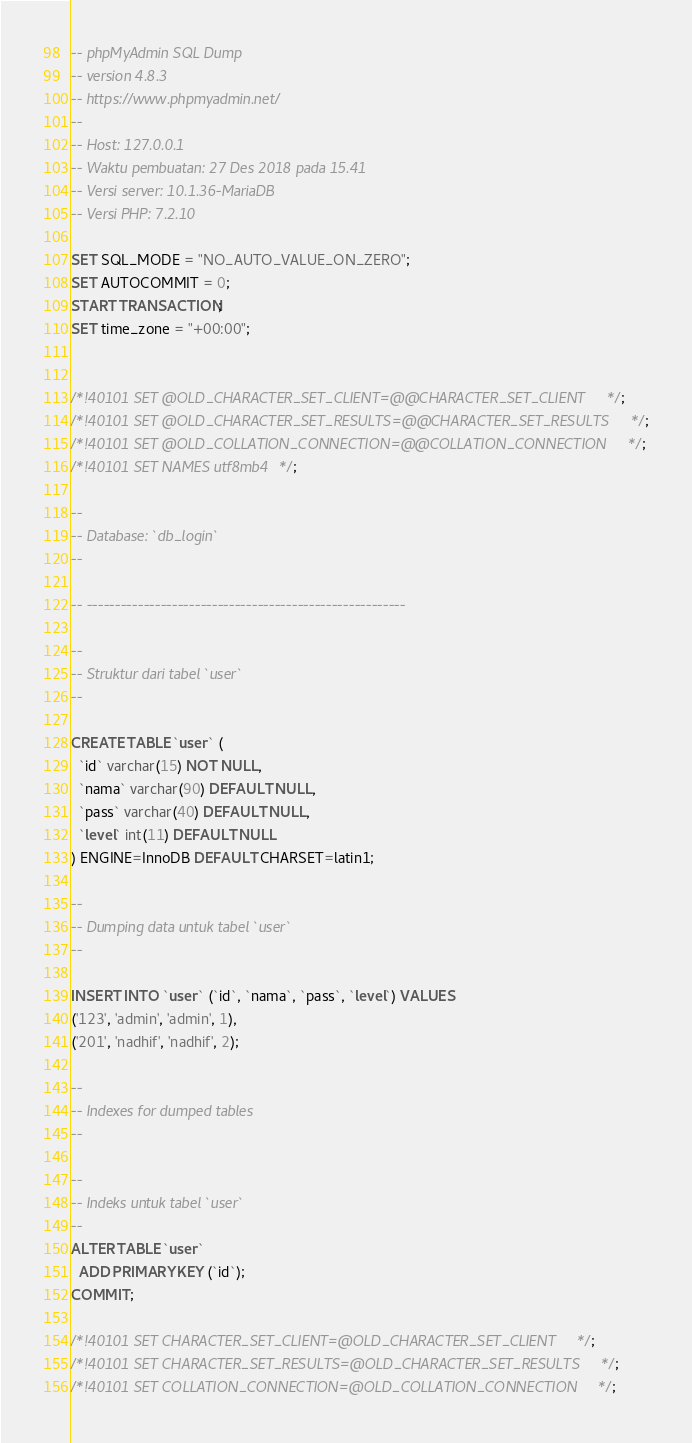Convert code to text. <code><loc_0><loc_0><loc_500><loc_500><_SQL_>-- phpMyAdmin SQL Dump
-- version 4.8.3
-- https://www.phpmyadmin.net/
--
-- Host: 127.0.0.1
-- Waktu pembuatan: 27 Des 2018 pada 15.41
-- Versi server: 10.1.36-MariaDB
-- Versi PHP: 7.2.10

SET SQL_MODE = "NO_AUTO_VALUE_ON_ZERO";
SET AUTOCOMMIT = 0;
START TRANSACTION;
SET time_zone = "+00:00";


/*!40101 SET @OLD_CHARACTER_SET_CLIENT=@@CHARACTER_SET_CLIENT */;
/*!40101 SET @OLD_CHARACTER_SET_RESULTS=@@CHARACTER_SET_RESULTS */;
/*!40101 SET @OLD_COLLATION_CONNECTION=@@COLLATION_CONNECTION */;
/*!40101 SET NAMES utf8mb4 */;

--
-- Database: `db_login`
--

-- --------------------------------------------------------

--
-- Struktur dari tabel `user`
--

CREATE TABLE `user` (
  `id` varchar(15) NOT NULL,
  `nama` varchar(90) DEFAULT NULL,
  `pass` varchar(40) DEFAULT NULL,
  `level` int(11) DEFAULT NULL
) ENGINE=InnoDB DEFAULT CHARSET=latin1;

--
-- Dumping data untuk tabel `user`
--

INSERT INTO `user` (`id`, `nama`, `pass`, `level`) VALUES
('123', 'admin', 'admin', 1),
('201', 'nadhif', 'nadhif', 2);

--
-- Indexes for dumped tables
--

--
-- Indeks untuk tabel `user`
--
ALTER TABLE `user`
  ADD PRIMARY KEY (`id`);
COMMIT;

/*!40101 SET CHARACTER_SET_CLIENT=@OLD_CHARACTER_SET_CLIENT */;
/*!40101 SET CHARACTER_SET_RESULTS=@OLD_CHARACTER_SET_RESULTS */;
/*!40101 SET COLLATION_CONNECTION=@OLD_COLLATION_CONNECTION */;
</code> 